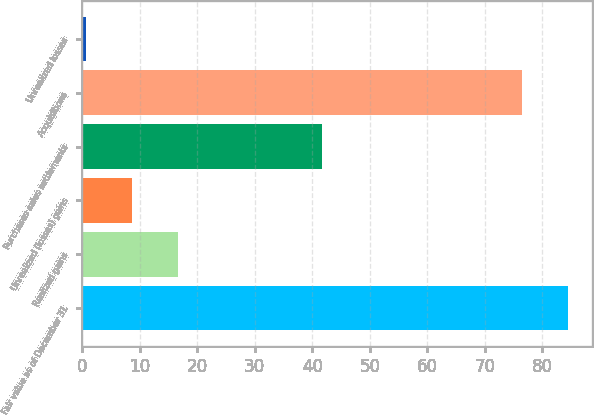<chart> <loc_0><loc_0><loc_500><loc_500><bar_chart><fcel>Fair value as of December 31<fcel>Realized gains<fcel>Unrealized (losses) gains<fcel>Purchases sales settlements<fcel>Acquisitions<fcel>Unrealized losses<nl><fcel>84.44<fcel>16.74<fcel>8.67<fcel>41.7<fcel>76.37<fcel>0.6<nl></chart> 